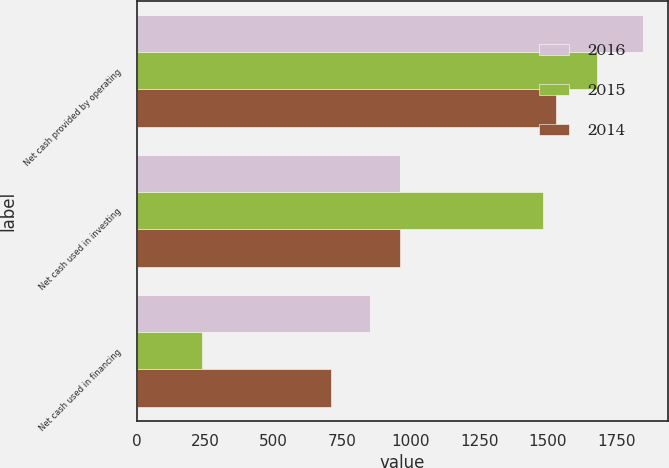Convert chart to OTSL. <chart><loc_0><loc_0><loc_500><loc_500><stacked_bar_chart><ecel><fcel>Net cash provided by operating<fcel>Net cash used in investing<fcel>Net cash used in financing<nl><fcel>2016<fcel>1847.8<fcel>961.2<fcel>851.2<nl><fcel>2015<fcel>1679.7<fcel>1482.8<fcel>239.7<nl><fcel>2014<fcel>1529.8<fcel>959.8<fcel>708.1<nl></chart> 